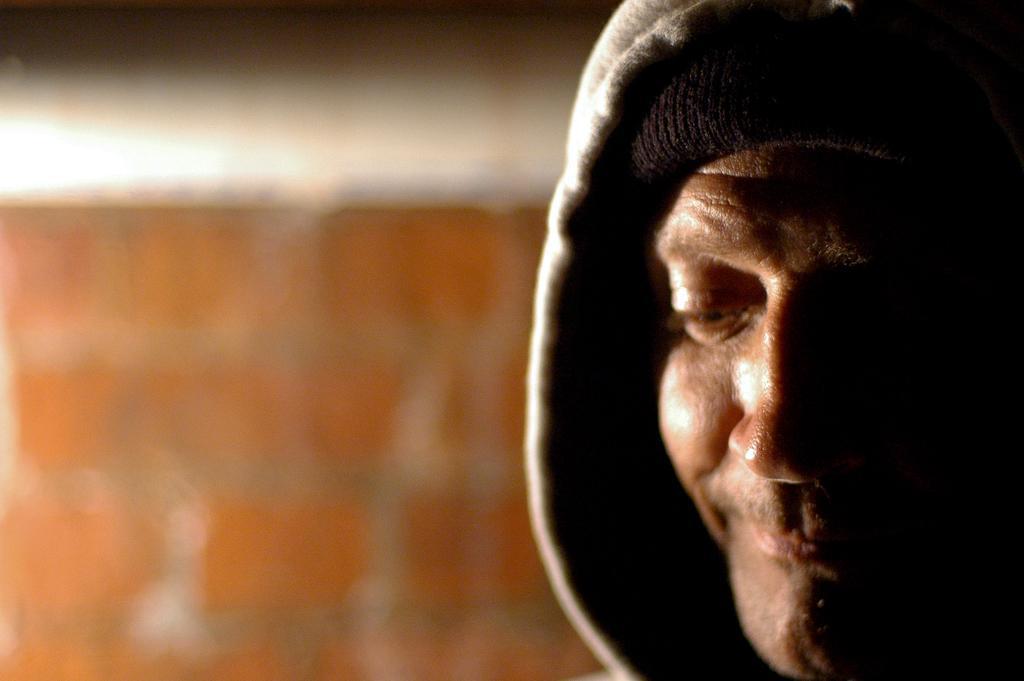Describe this image in one or two sentences. On the right side of the picture we can see a person face. In the background it is blur. 